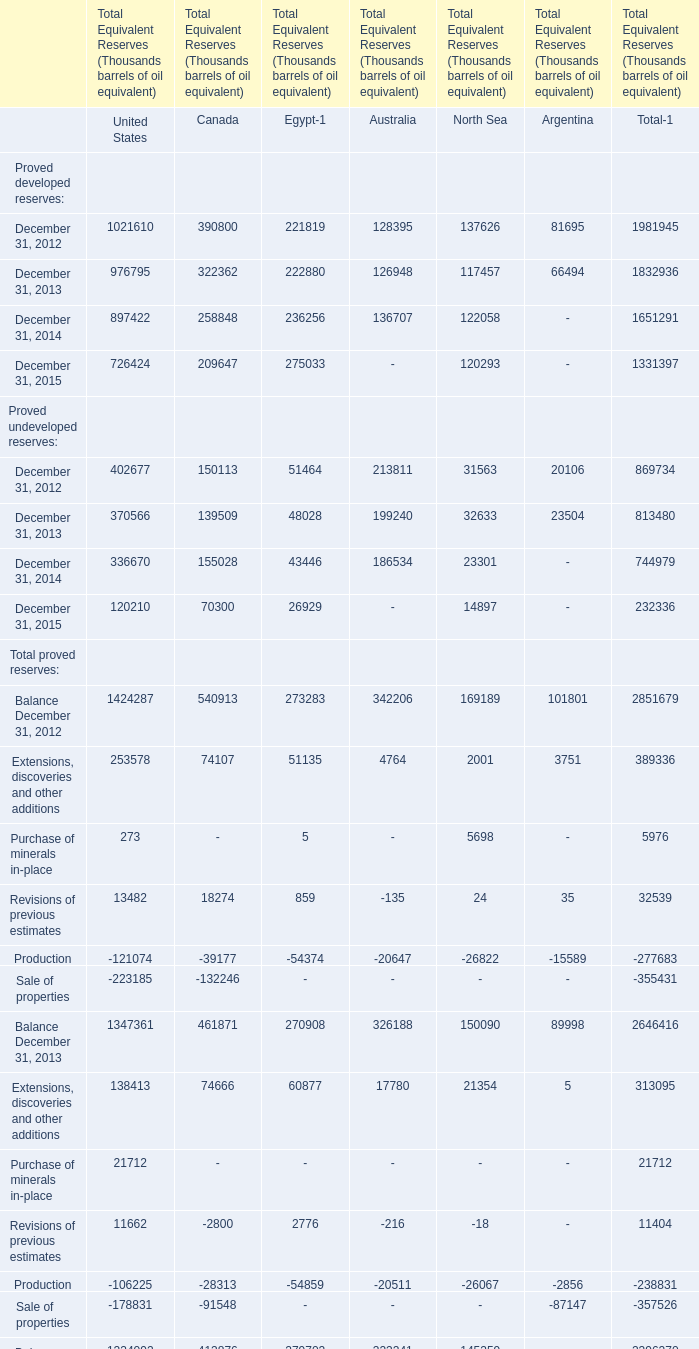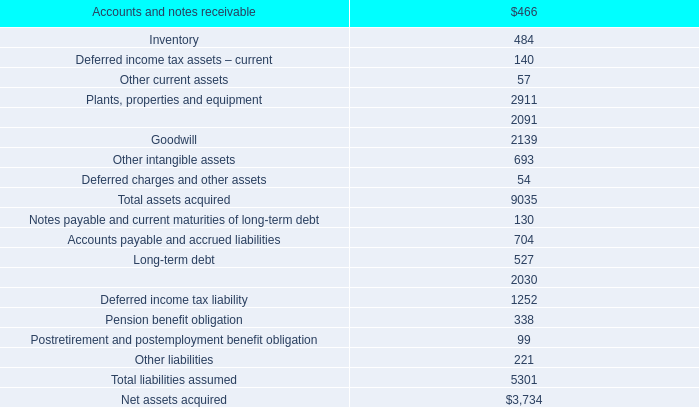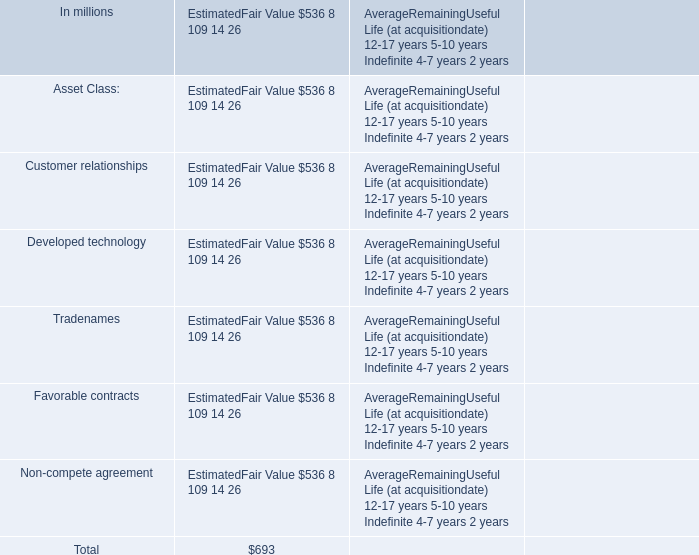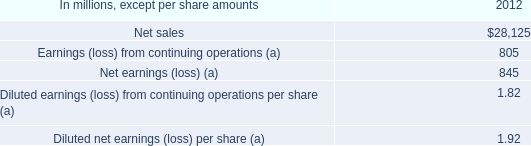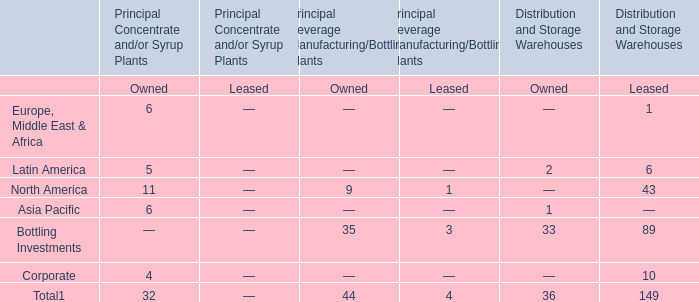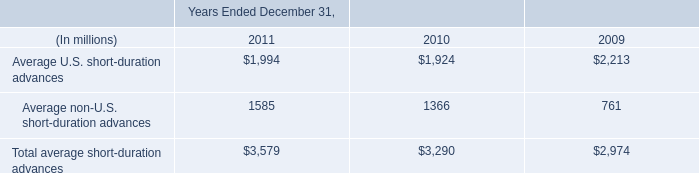What will Proved developed reserves be like in 2014 if it continues to grow at the same rate as it did in 2013? (in Thousand) 
Computations: (1832936 * (1 + ((1832936 - 1981945) / 1981945)))
Answer: 1695129.97591. 